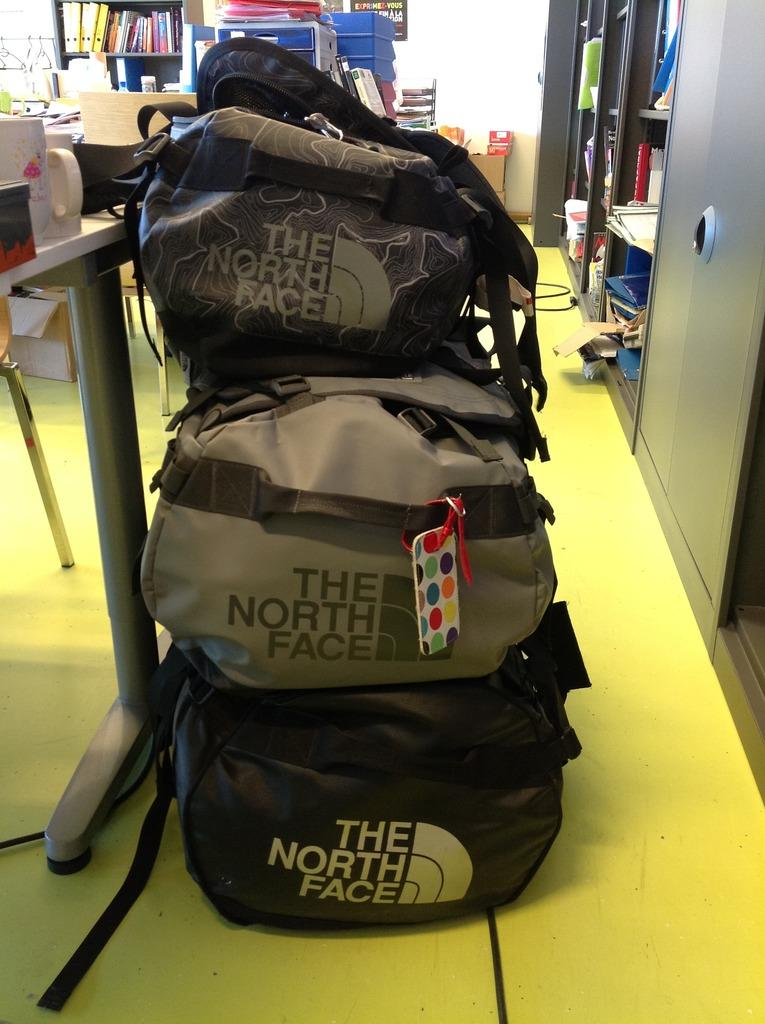What object is visible in the image? There is a backpack in the image. What can be seen in the background of the image? There are books in the shelves in the background of the image. How does the son contribute to the image? There is no son present in the image. What type of curve can be seen in the image? There are no curves visible in the image. 